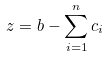Convert formula to latex. <formula><loc_0><loc_0><loc_500><loc_500>z = b - \sum _ { i = 1 } ^ { n } c _ { i }</formula> 